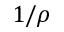<formula> <loc_0><loc_0><loc_500><loc_500>1 / \rho</formula> 